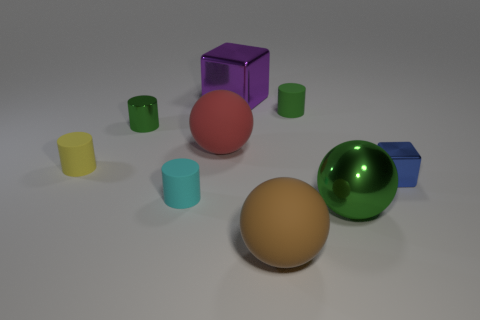Are there any other things that are the same size as the yellow rubber object?
Ensure brevity in your answer.  Yes. What shape is the tiny shiny thing that is the same color as the big metallic ball?
Provide a short and direct response. Cylinder. Are there fewer tiny blue metallic things that are on the right side of the large red thing than big brown objects left of the yellow matte cylinder?
Your response must be concise. No. The green object that is both right of the small green metal cylinder and behind the green metal sphere is made of what material?
Provide a succinct answer. Rubber. Is the shape of the purple metal thing the same as the tiny metallic object left of the red matte thing?
Your answer should be very brief. No. How many other objects are there of the same size as the blue metallic block?
Your answer should be compact. 4. Is the number of tiny green rubber things greater than the number of large purple spheres?
Provide a short and direct response. Yes. What number of large objects are to the left of the big purple block and in front of the cyan rubber object?
Make the answer very short. 0. There is a small shiny object that is left of the large metal thing left of the rubber sphere to the right of the big purple shiny object; what is its shape?
Your response must be concise. Cylinder. Is there any other thing that is the same shape as the large red rubber object?
Keep it short and to the point. Yes. 